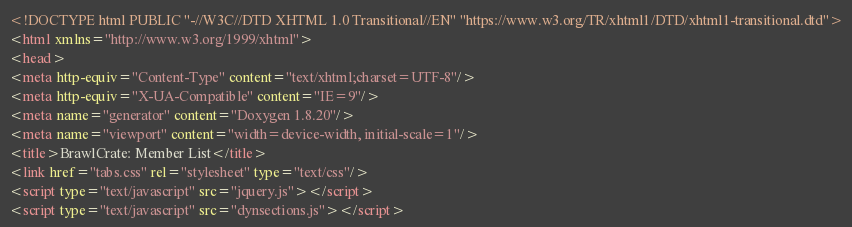Convert code to text. <code><loc_0><loc_0><loc_500><loc_500><_HTML_><!DOCTYPE html PUBLIC "-//W3C//DTD XHTML 1.0 Transitional//EN" "https://www.w3.org/TR/xhtml1/DTD/xhtml1-transitional.dtd">
<html xmlns="http://www.w3.org/1999/xhtml">
<head>
<meta http-equiv="Content-Type" content="text/xhtml;charset=UTF-8"/>
<meta http-equiv="X-UA-Compatible" content="IE=9"/>
<meta name="generator" content="Doxygen 1.8.20"/>
<meta name="viewport" content="width=device-width, initial-scale=1"/>
<title>BrawlCrate: Member List</title>
<link href="tabs.css" rel="stylesheet" type="text/css"/>
<script type="text/javascript" src="jquery.js"></script>
<script type="text/javascript" src="dynsections.js"></script></code> 